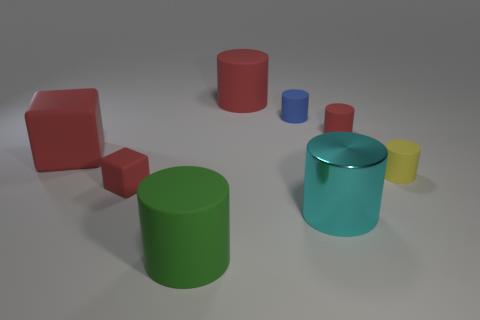Subtract all large green rubber cylinders. How many cylinders are left? 5 Subtract all blue cylinders. How many cylinders are left? 5 Subtract all purple cylinders. Subtract all red balls. How many cylinders are left? 6 Add 1 large cylinders. How many objects exist? 9 Add 6 tiny blue cylinders. How many tiny blue cylinders exist? 7 Subtract 1 yellow cylinders. How many objects are left? 7 Subtract all blocks. How many objects are left? 6 Subtract all big green objects. Subtract all yellow matte objects. How many objects are left? 6 Add 6 big red things. How many big red things are left? 8 